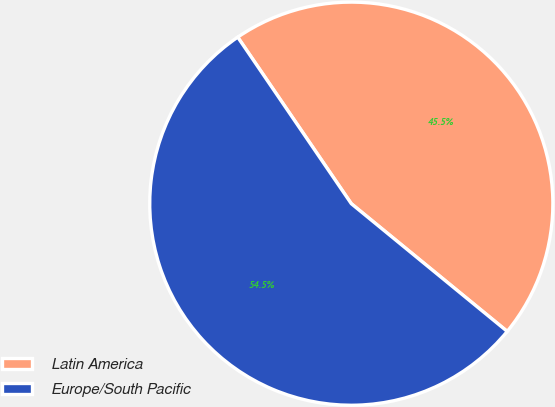Convert chart. <chart><loc_0><loc_0><loc_500><loc_500><pie_chart><fcel>Latin America<fcel>Europe/South Pacific<nl><fcel>45.45%<fcel>54.55%<nl></chart> 